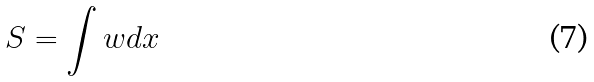Convert formula to latex. <formula><loc_0><loc_0><loc_500><loc_500>S = \int w d x</formula> 